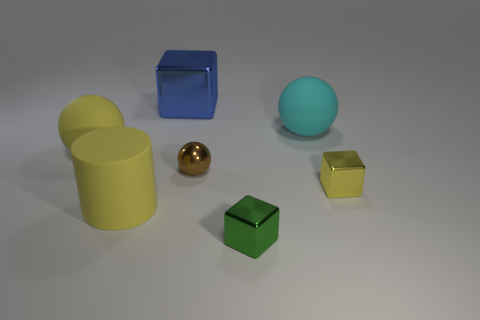There is a ball that is the same color as the rubber cylinder; what is its material?
Your answer should be compact. Rubber. What number of shiny blocks are the same color as the rubber cylinder?
Give a very brief answer. 1. There is a rubber thing that is the same color as the matte cylinder; what is its size?
Offer a very short reply. Large. Are there any green things made of the same material as the yellow sphere?
Ensure brevity in your answer.  No. What number of big rubber balls are right of the yellow matte ball and in front of the big cyan rubber sphere?
Provide a short and direct response. 0. There is a object behind the cyan sphere; what is it made of?
Keep it short and to the point. Metal. There is a yellow object that is made of the same material as the tiny brown ball; what is its size?
Keep it short and to the point. Small. There is a small yellow block; are there any blue objects to the left of it?
Your answer should be very brief. Yes. There is a yellow rubber thing that is the same shape as the large cyan matte thing; what is its size?
Your answer should be very brief. Large. There is a big rubber cylinder; does it have the same color as the small shiny thing in front of the big cylinder?
Offer a terse response. No. 